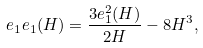Convert formula to latex. <formula><loc_0><loc_0><loc_500><loc_500>e _ { 1 } e _ { 1 } ( H ) = \frac { 3 e _ { 1 } ^ { 2 } ( H ) } { 2 H } - 8 H ^ { 3 } ,</formula> 